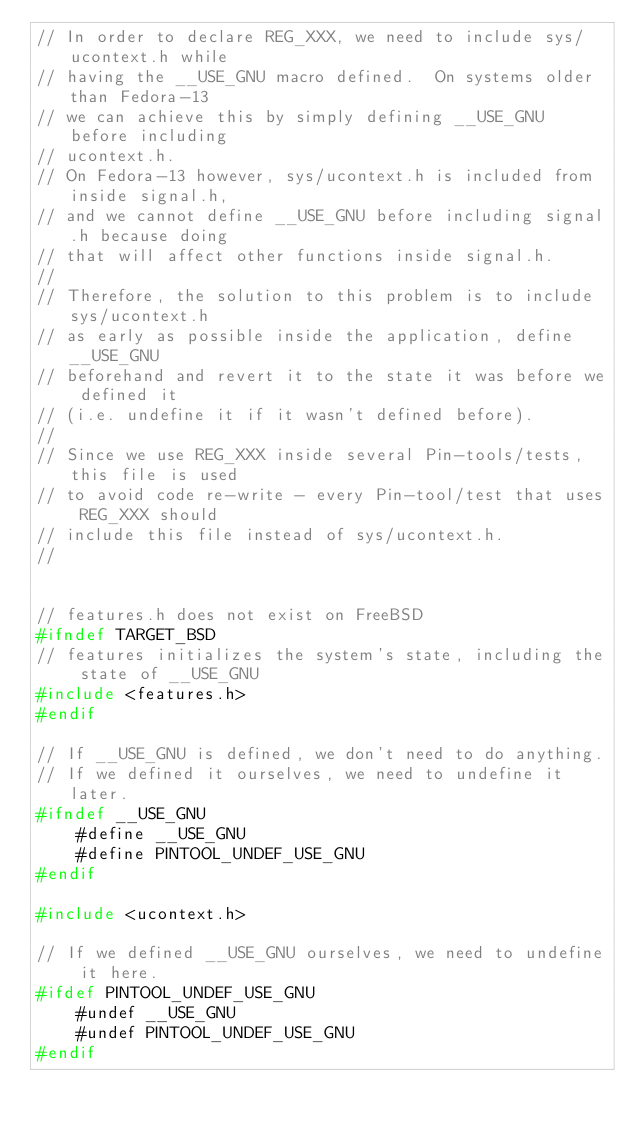Convert code to text. <code><loc_0><loc_0><loc_500><loc_500><_C_>// In order to declare REG_XXX, we need to include sys/ucontext.h while
// having the __USE_GNU macro defined.  On systems older than Fedora-13
// we can achieve this by simply defining __USE_GNU before including
// ucontext.h.
// On Fedora-13 however, sys/ucontext.h is included from inside signal.h,
// and we cannot define __USE_GNU before including signal.h because doing
// that will affect other functions inside signal.h.
//
// Therefore, the solution to this problem is to include sys/ucontext.h
// as early as possible inside the application, define __USE_GNU
// beforehand and revert it to the state it was before we defined it
// (i.e. undefine it if it wasn't defined before).
//
// Since we use REG_XXX inside several Pin-tools/tests, this file is used
// to avoid code re-write - every Pin-tool/test that uses REG_XXX should
// include this file instead of sys/ucontext.h.
//


// features.h does not exist on FreeBSD
#ifndef TARGET_BSD
// features initializes the system's state, including the state of __USE_GNU 
#include <features.h>
#endif

// If __USE_GNU is defined, we don't need to do anything.
// If we defined it ourselves, we need to undefine it later.
#ifndef __USE_GNU
    #define __USE_GNU
    #define PINTOOL_UNDEF_USE_GNU
#endif

#include <ucontext.h>

// If we defined __USE_GNU ourselves, we need to undefine it here.
#ifdef PINTOOL_UNDEF_USE_GNU
    #undef __USE_GNU
    #undef PINTOOL_UNDEF_USE_GNU
#endif
</code> 